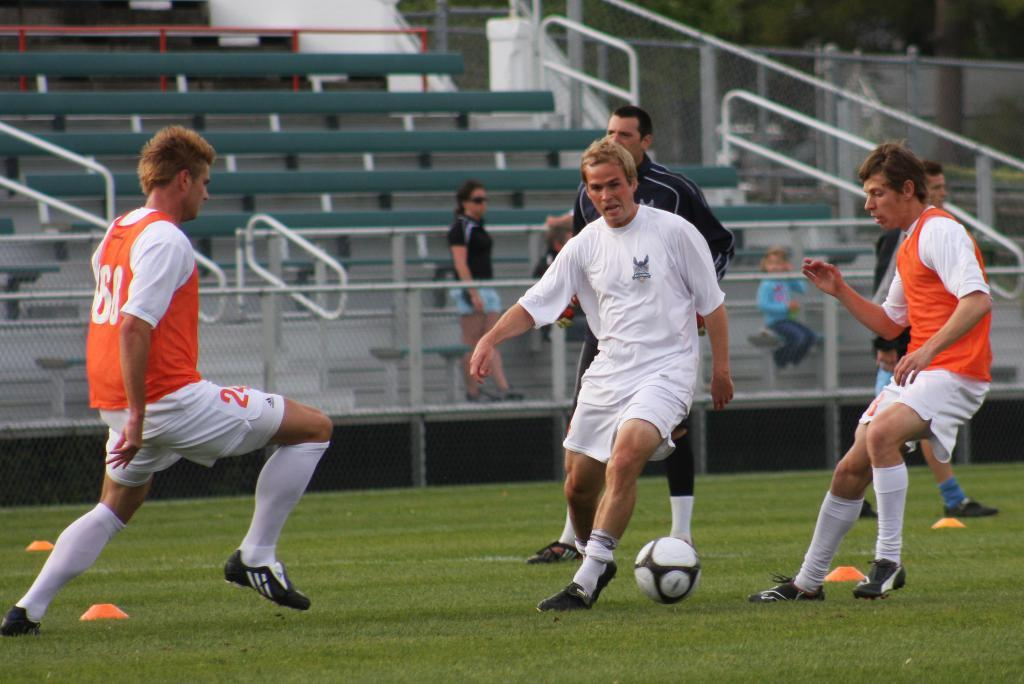What is the main setting of the image? The image depicts a field. How many sports people are visible in the image? There are three sports people in the image. What are the sports people doing in the image? The sports people are playing with a ball. What type of pump can be seen in the image? There is no pump present in the image. Is the sports person's father visible in the image? The image does not provide information about the relationship between the sports people and their family members, so it cannot be determined if the father is present. 